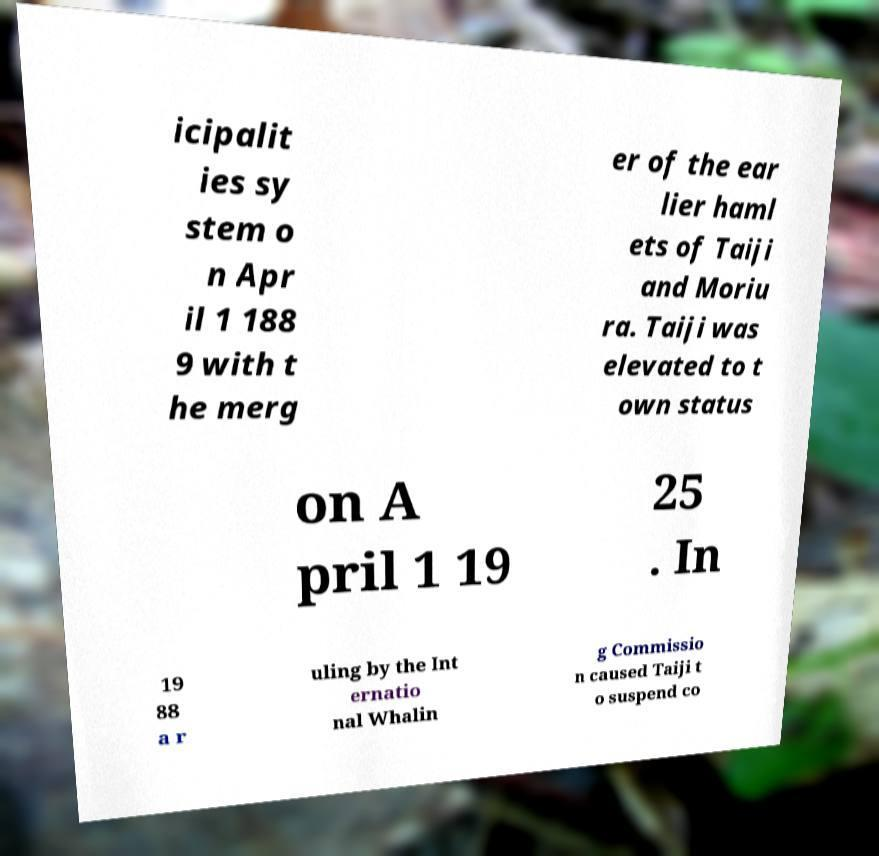Could you assist in decoding the text presented in this image and type it out clearly? icipalit ies sy stem o n Apr il 1 188 9 with t he merg er of the ear lier haml ets of Taiji and Moriu ra. Taiji was elevated to t own status on A pril 1 19 25 . In 19 88 a r uling by the Int ernatio nal Whalin g Commissio n caused Taiji t o suspend co 